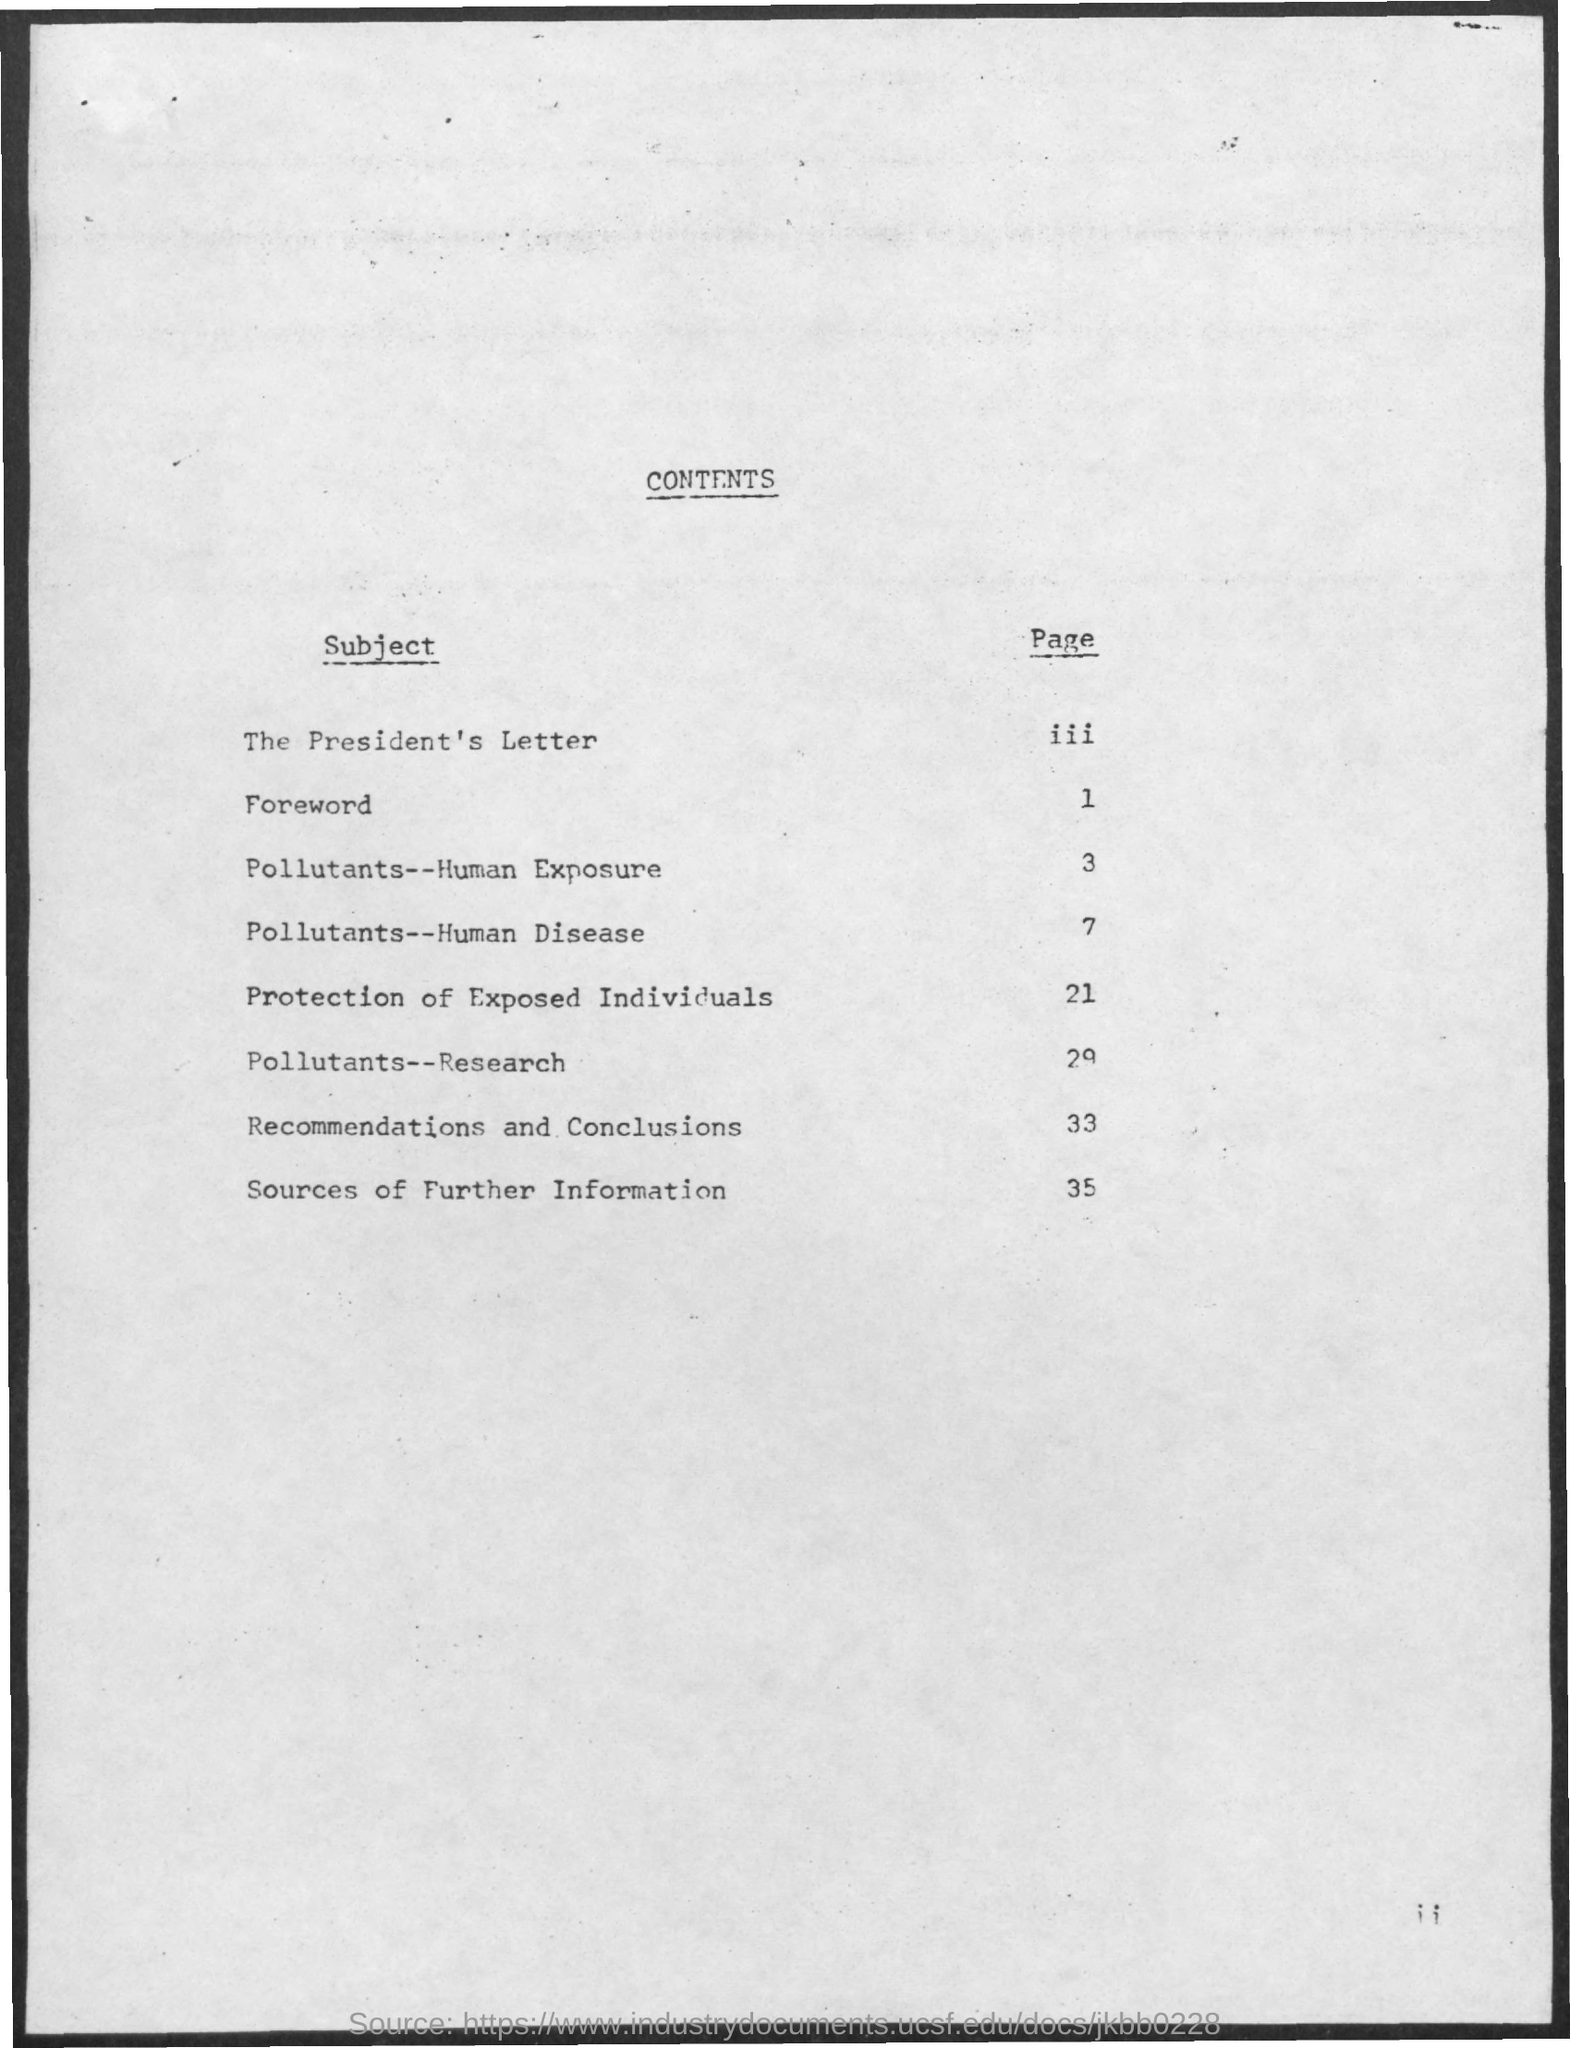List a handful of essential elements in this visual. The pollutants are the research subject, and the page number for this topic is 29. The page number for protecting individuals who have been exposed is 21. The page number for recommendations and conclusions is 33. The page number for information on pollutants and their impact on human disease is 7. The page number for the subject of pollutants-- human exposure is 3. 